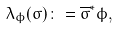Convert formula to latex. <formula><loc_0><loc_0><loc_500><loc_500>\lambda _ { \phi } ( \sigma ) \colon = \overline { \sigma } ^ { * } \phi ,</formula> 